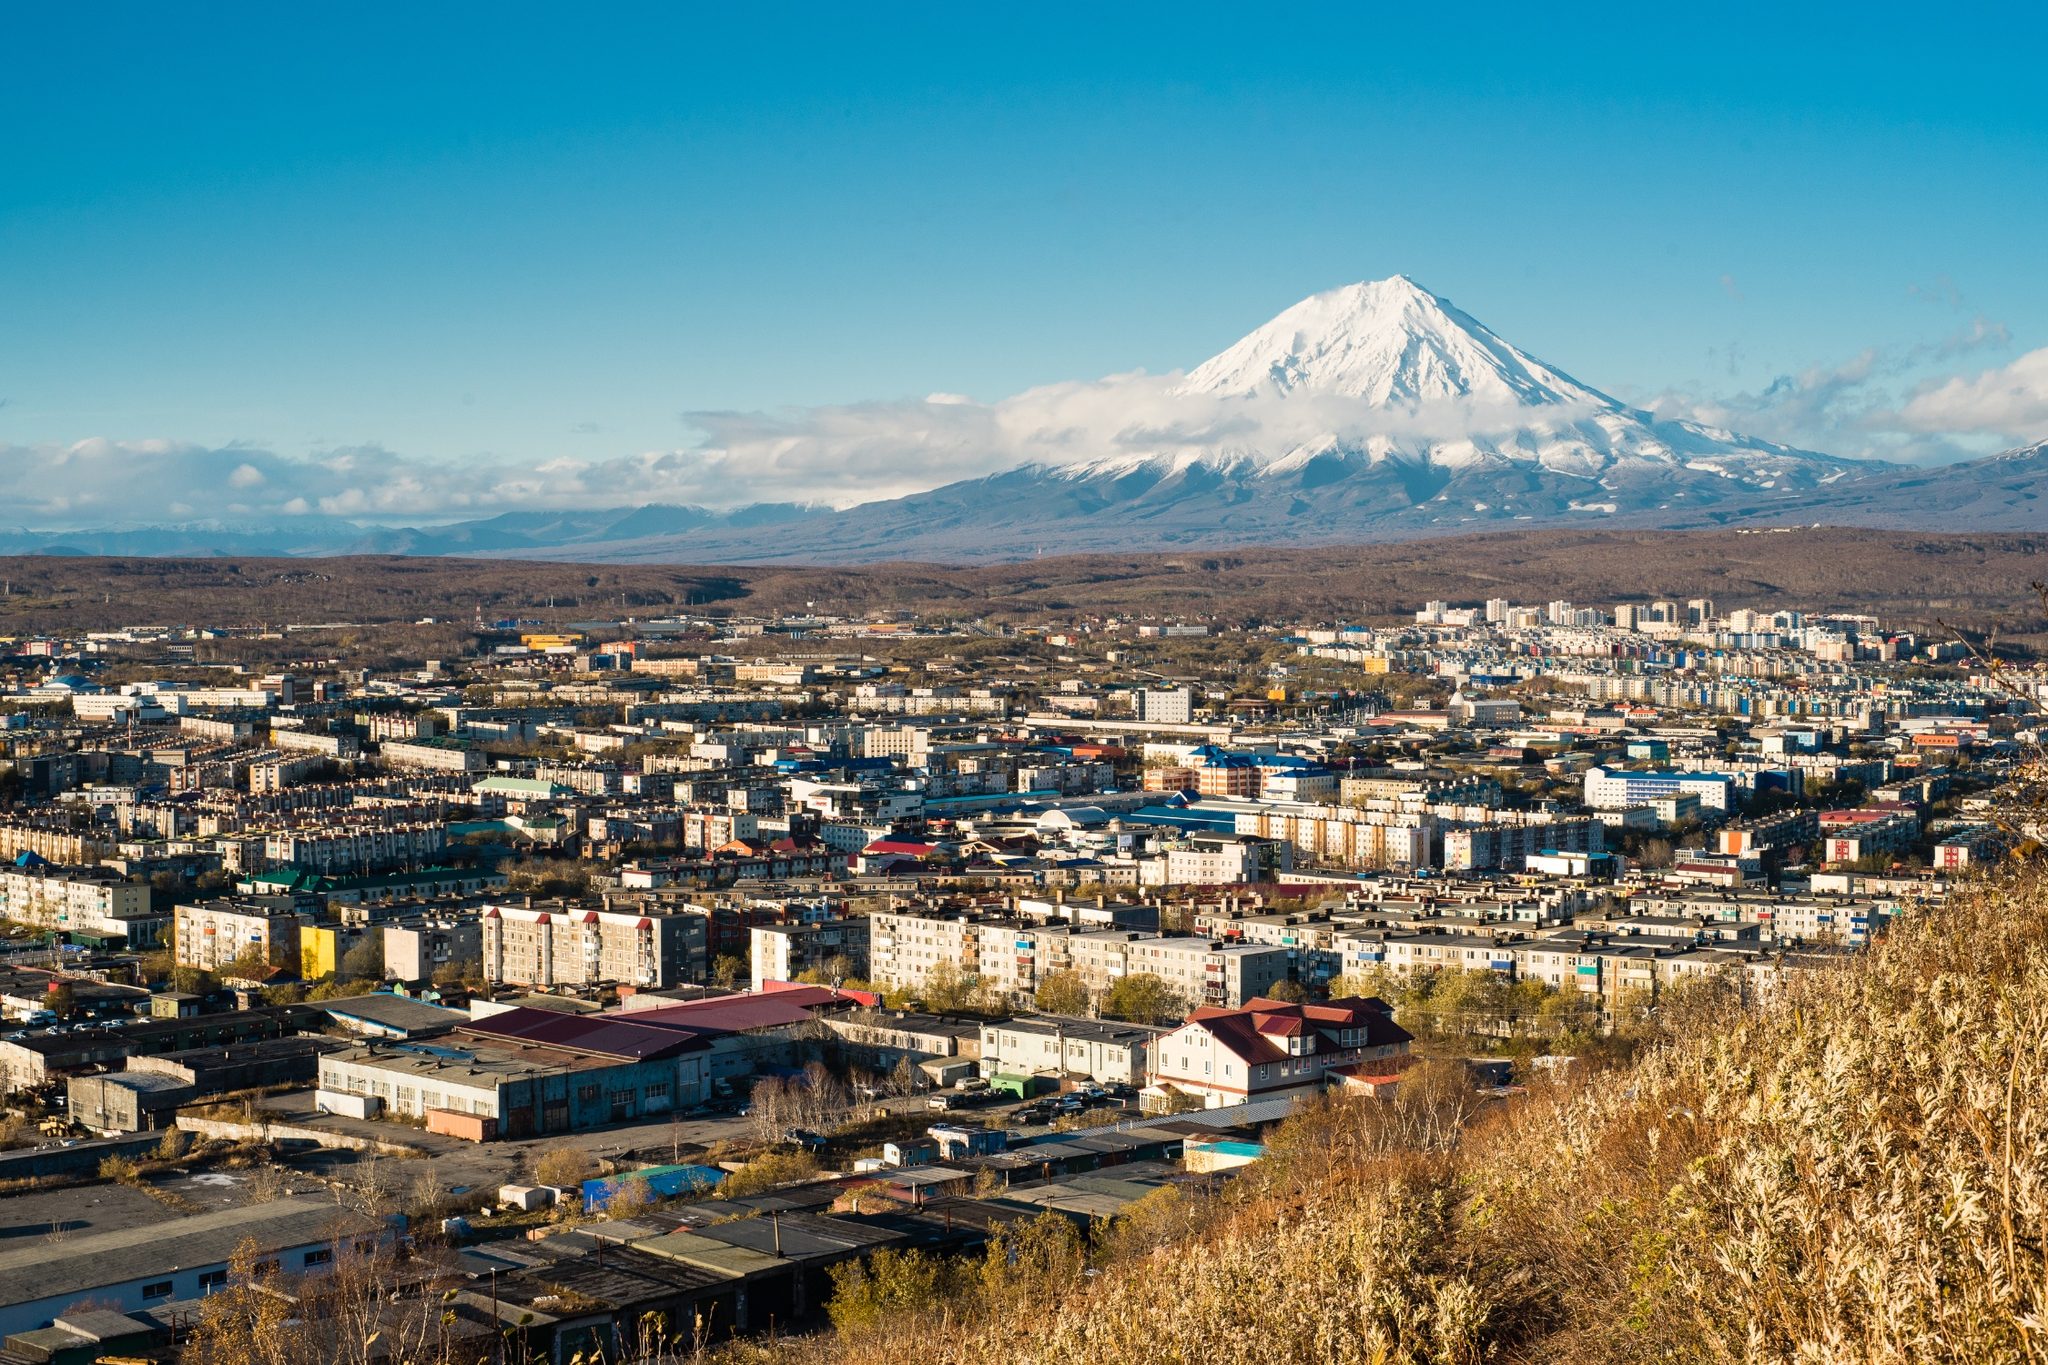Can you elaborate on the elements of the picture provided? The image showcases a stunning view of Petropavlovsk-Kamchatsky, a city in Russia, located at the base of the impressive Koryaksky volcano. The urban layout is densely packed with an assortment of buildings, ranging from residential apartments to various commercial establishments. This dense urban setting starkly contrasts with the raw, natural splendor of the snow-covered Koryaksky volcano standing proudly in the background. The photograph appears to have been taken from an elevated position, offering a sweeping view of the city’s intricate layout and the dominating presence of the volcano. The bright, clear blue sky adds a striking contrast, enriching the overall visual experience. The mention of 'sa_1101' implies that this image might be part of a larger collection or series, which might present other breathtaking scenes from the region. Altogether, the image marvelously blends urban development with the untouched beauty of nature, highlighting the unique allure of Petropavlovsk-Kamchatsky. 